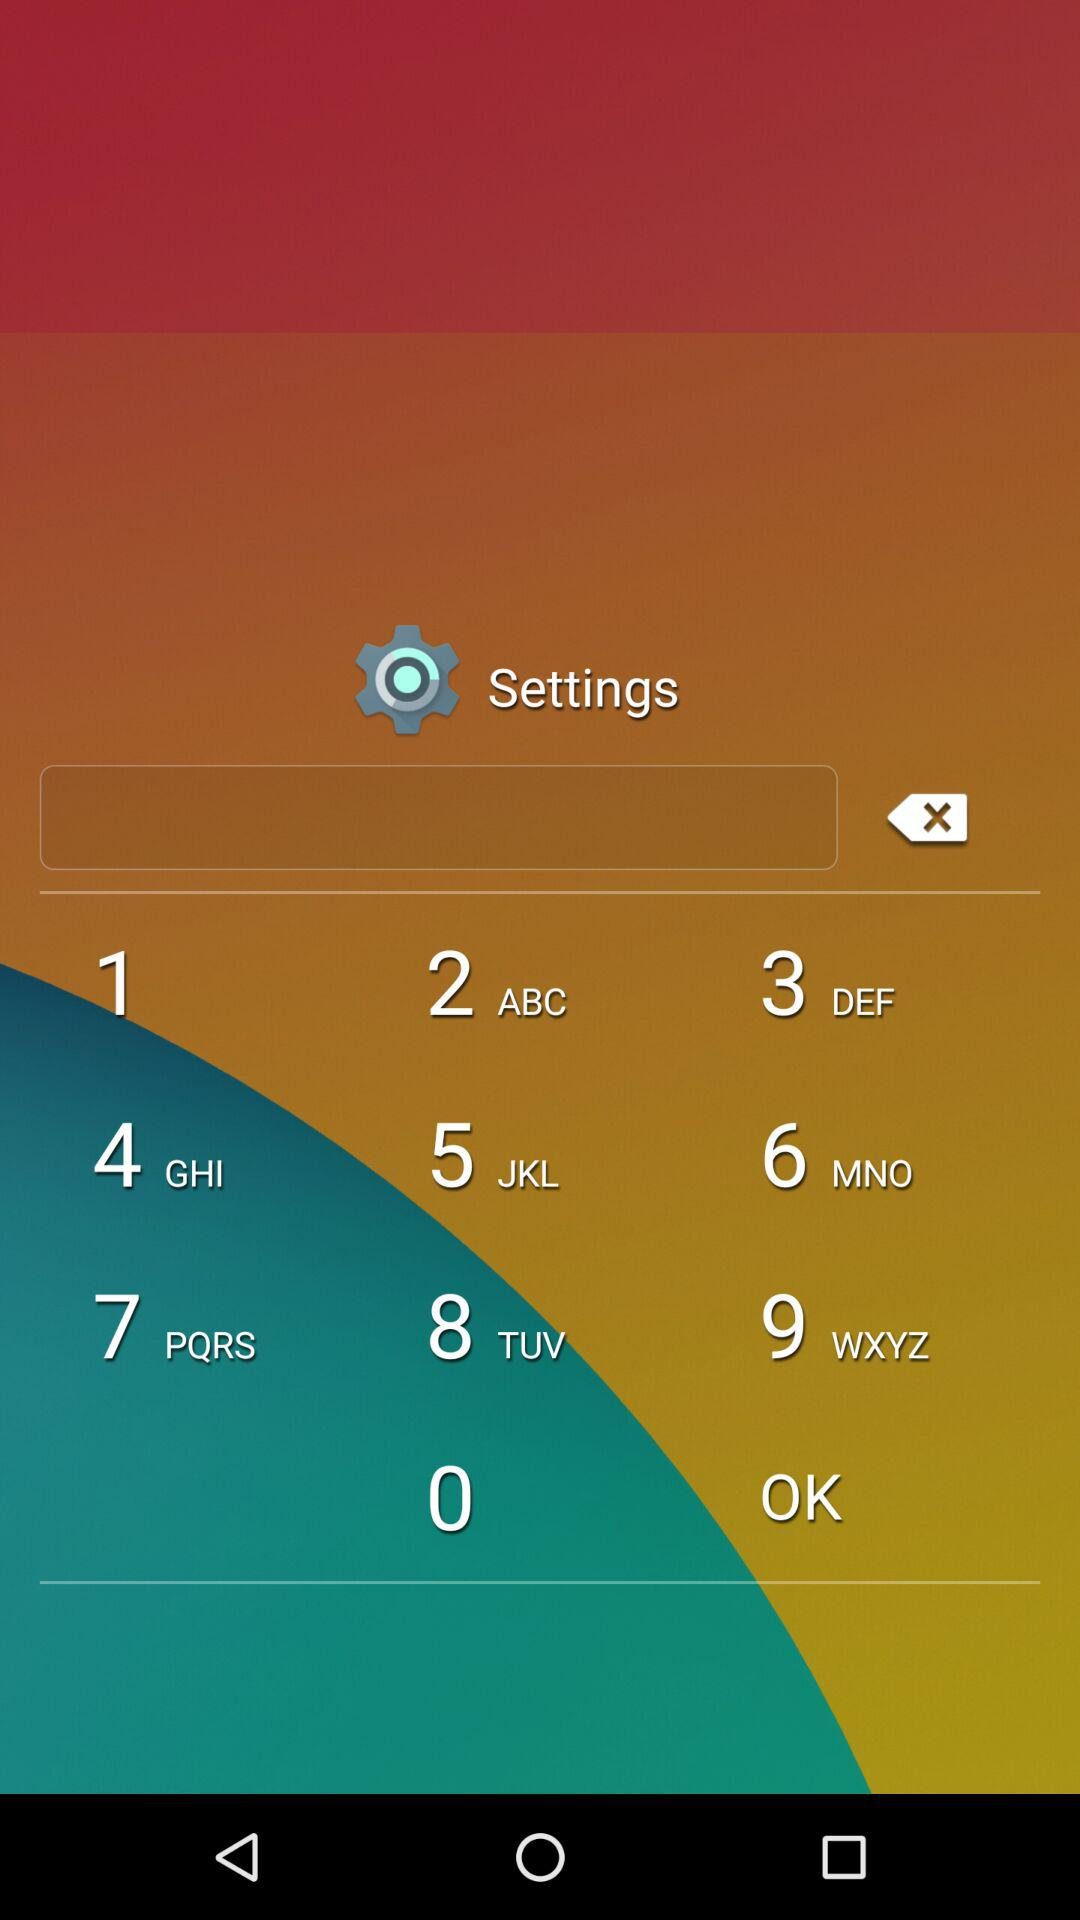How many different subscription plans are there?
Answer the question using a single word or phrase. 2 